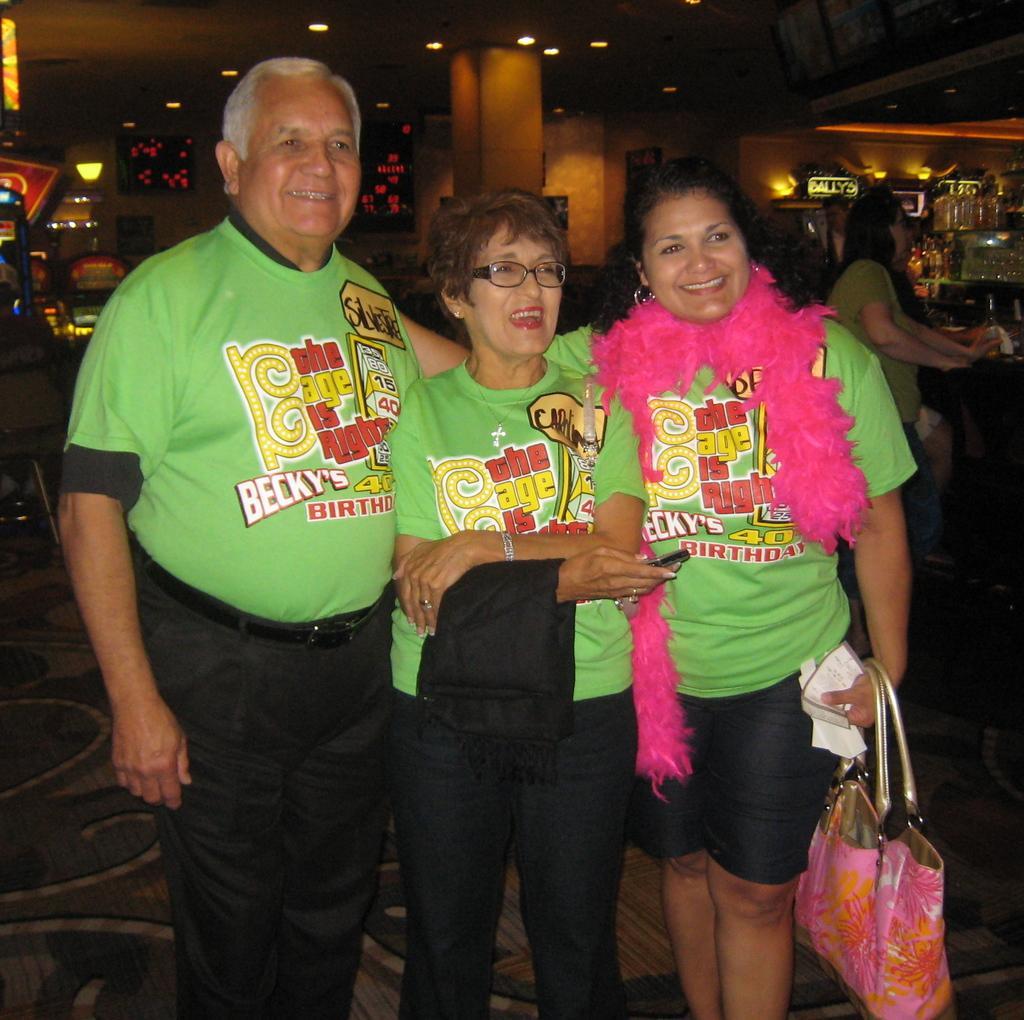In one or two sentences, can you explain what this image depicts? On the left an old man is standing in the middle an old woman is there in the right a lady standing by holding a bag. 